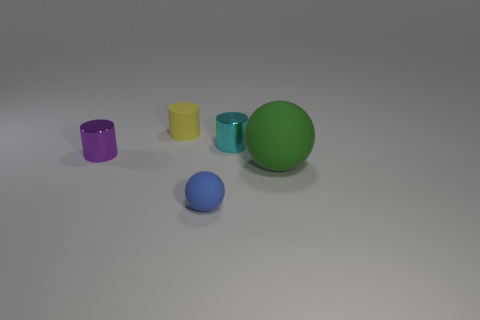Add 1 purple cylinders. How many objects exist? 6 Subtract all balls. How many objects are left? 3 Add 5 large purple metal cylinders. How many large purple metal cylinders exist? 5 Subtract 0 purple cubes. How many objects are left? 5 Subtract all small yellow rubber blocks. Subtract all big rubber objects. How many objects are left? 4 Add 1 small purple things. How many small purple things are left? 2 